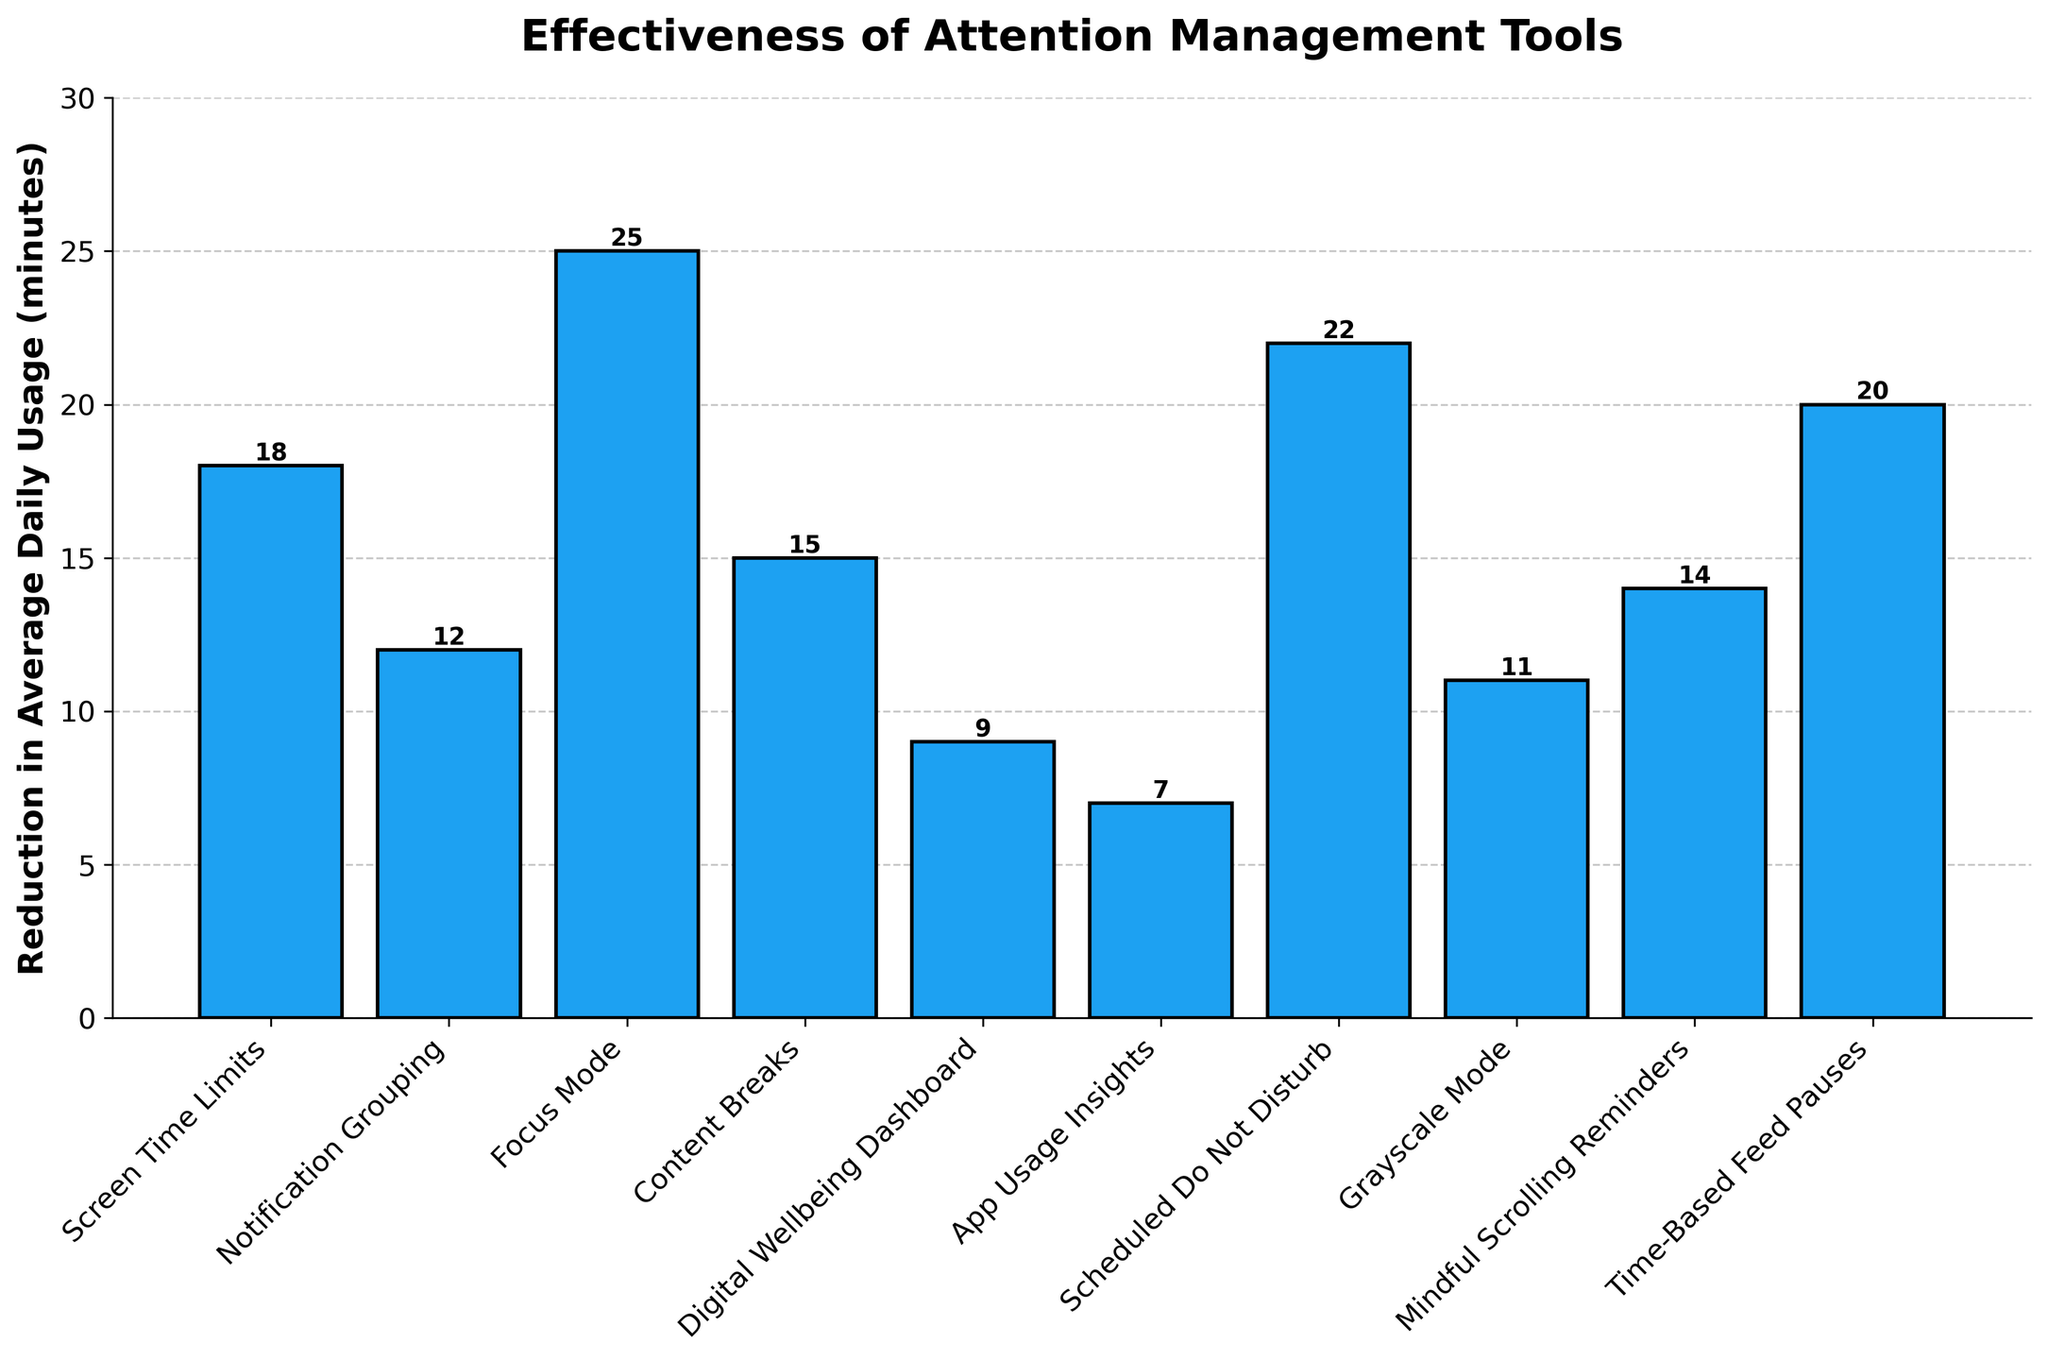Which attention management tool is the most effective in reducing average daily usage time? The most effective tool will have the highest bar on the chart. By looking at the chart, Focus Mode has the highest bar.
Answer: Focus Mode How much more effective is Scheduled Do Not Disturb compared to Grayscale Mode? Subtract the reduction in average daily usage time of Grayscale Mode from Scheduled Do Not Disturb. Scheduled Do Not Disturb has a reduction of 22 minutes, and Grayscale Mode has 11 minutes. 22 - 11 = 11 minutes.
Answer: 11 minutes What is the combined reduction in average daily usage time for Content Breaks and Time-Based Feed Pauses? Add the reduction in average daily usage time for Content Breaks and Time-Based Feed Pauses. Content Breaks has 15 minutes, and Time-Based Feed Pauses has 20 minutes. 15 + 20 = 35 minutes.
Answer: 35 minutes How much less effective is App Usage Insights compared to Notification Grouping? Subtract the reduction in average daily usage time of App Usage Insights from Notification Grouping. Notification Grouping has 12 minutes, and App Usage Insights has 7 minutes. 12 - 7 = 5 minutes.
Answer: 5 minutes Which tool has a reduction close to the median value of all tools? To find the median, first list the reduction values in ascending order: 7, 9, 11, 12, 14, 15, 18, 20, 22, 25. The median is the middle number in this list. Since the list has 10 values, the median is the average of the 5th and 6th values: (14 + 15) / 2 = 14.5. Mindful Scrolling Reminders and Content Breaks have values close to 14.5.
Answer: Mindful Scrolling Reminders, Content Breaks Does any tool have a reduction that is less than half the reduction of the most effective tool? The most effective tool is Focus Mode with a reduction of 25 minutes. Half of this reduction is 12.5 minutes. Tools with reductions less than 12.5 minutes are Notification Grouping, Digital Wellbeing Dashboard, App Usage Insights, and Grayscale Mode.
Answer: Notification Grouping, Digital Wellbeing Dashboard, App Usage Insights, Grayscale Mode What is the total reduction in average daily usage time for all tools combined? Add the reduction in average daily usage time for all tools. The reductions are: 18, 12, 25, 15, 9, 7, 22, 11, 14, and 20. The total is 18 + 12 + 25 + 15 + 9 + 7 + 22 + 11 + 14 + 20 = 153 minutes.
Answer: 153 minutes 